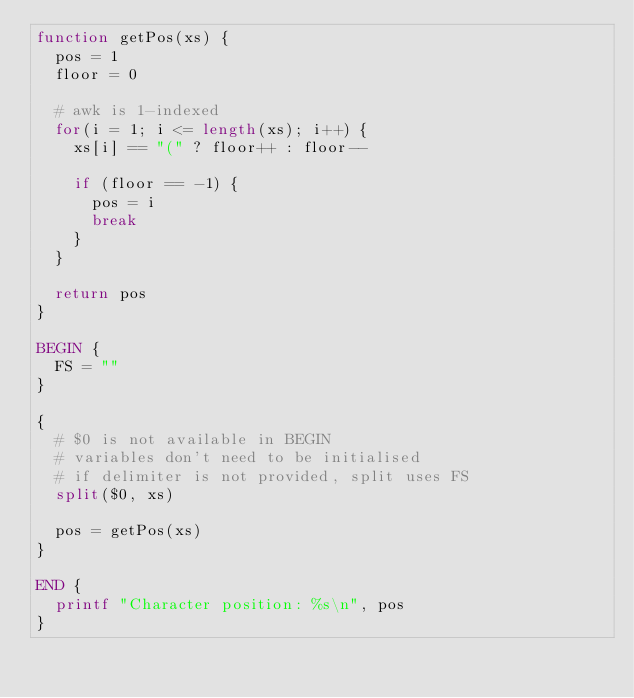<code> <loc_0><loc_0><loc_500><loc_500><_Awk_>function getPos(xs) {
  pos = 1
  floor = 0

  # awk is 1-indexed
  for(i = 1; i <= length(xs); i++) {
    xs[i] == "(" ? floor++ : floor--

    if (floor == -1) {
      pos = i
      break
    }
  }

  return pos
}

BEGIN {
  FS = ""
}

{
  # $0 is not available in BEGIN
  # variables don't need to be initialised
  # if delimiter is not provided, split uses FS
  split($0, xs)

  pos = getPos(xs)
}

END {
  printf "Character position: %s\n", pos
}
</code> 